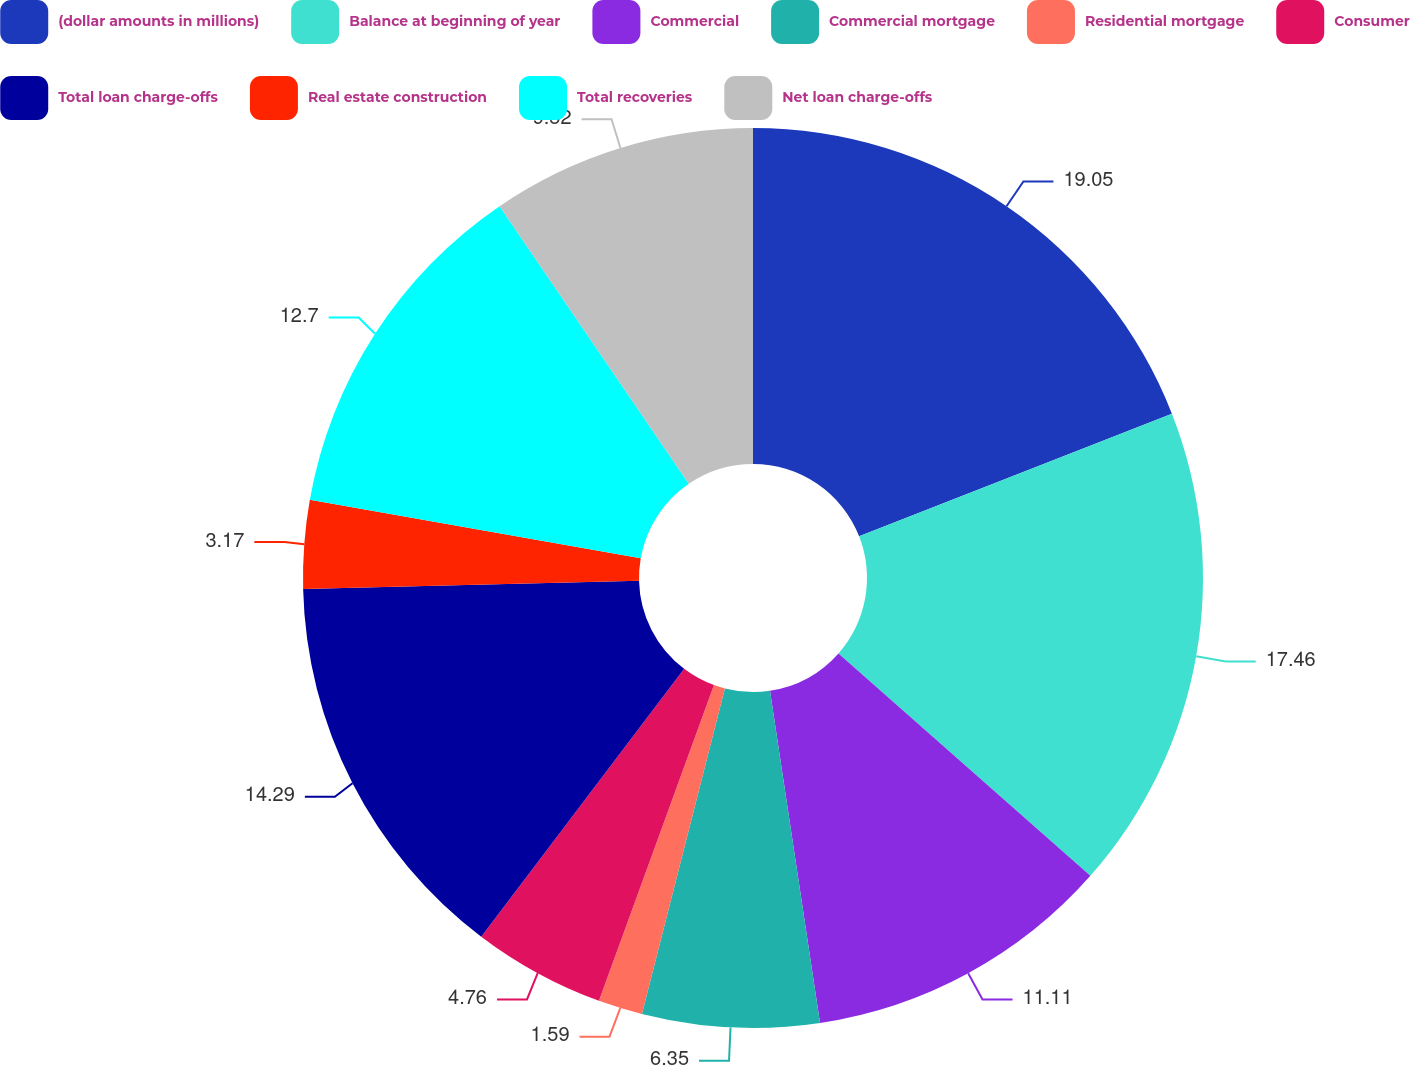<chart> <loc_0><loc_0><loc_500><loc_500><pie_chart><fcel>(dollar amounts in millions)<fcel>Balance at beginning of year<fcel>Commercial<fcel>Commercial mortgage<fcel>Residential mortgage<fcel>Consumer<fcel>Total loan charge-offs<fcel>Real estate construction<fcel>Total recoveries<fcel>Net loan charge-offs<nl><fcel>19.05%<fcel>17.46%<fcel>11.11%<fcel>6.35%<fcel>1.59%<fcel>4.76%<fcel>14.29%<fcel>3.17%<fcel>12.7%<fcel>9.52%<nl></chart> 